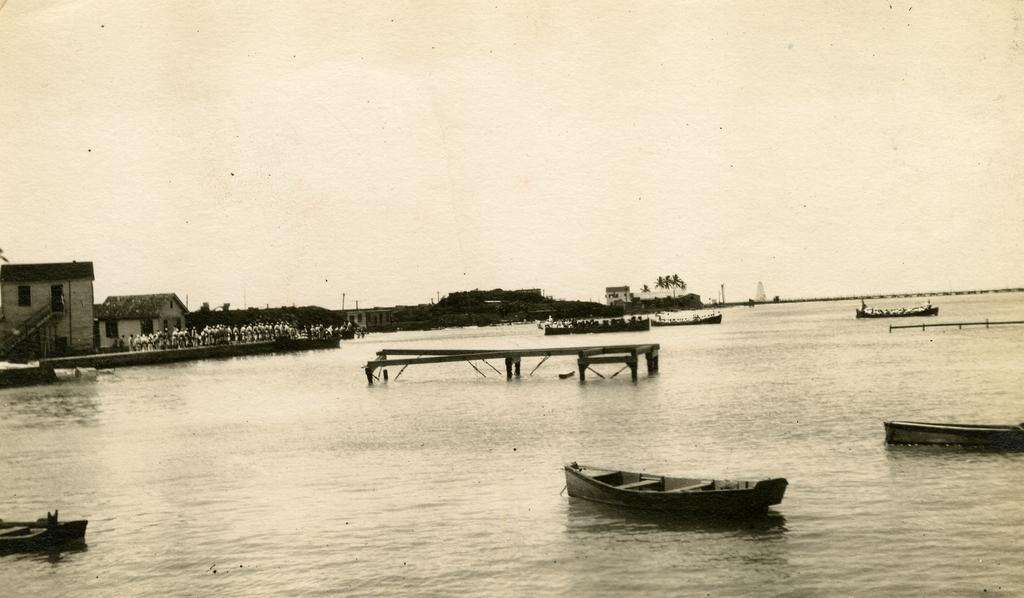What is happening on the water in the image? There are ships sailing on the water in the image. Where are the people located in the image? There is a group of people on the left side of the image. What type of structures can be seen in the image? There are houses visible in the image. What type of vegetation is present in the image? There are trees in the image. What type of twig is being used to order the ships in the image? There is no twig or order being used to control the ships in the image; they are sailing on the water. What type of place is depicted in the image? The image does not depict a specific place; it shows ships sailing on the water, a group of people, houses, and trees. 